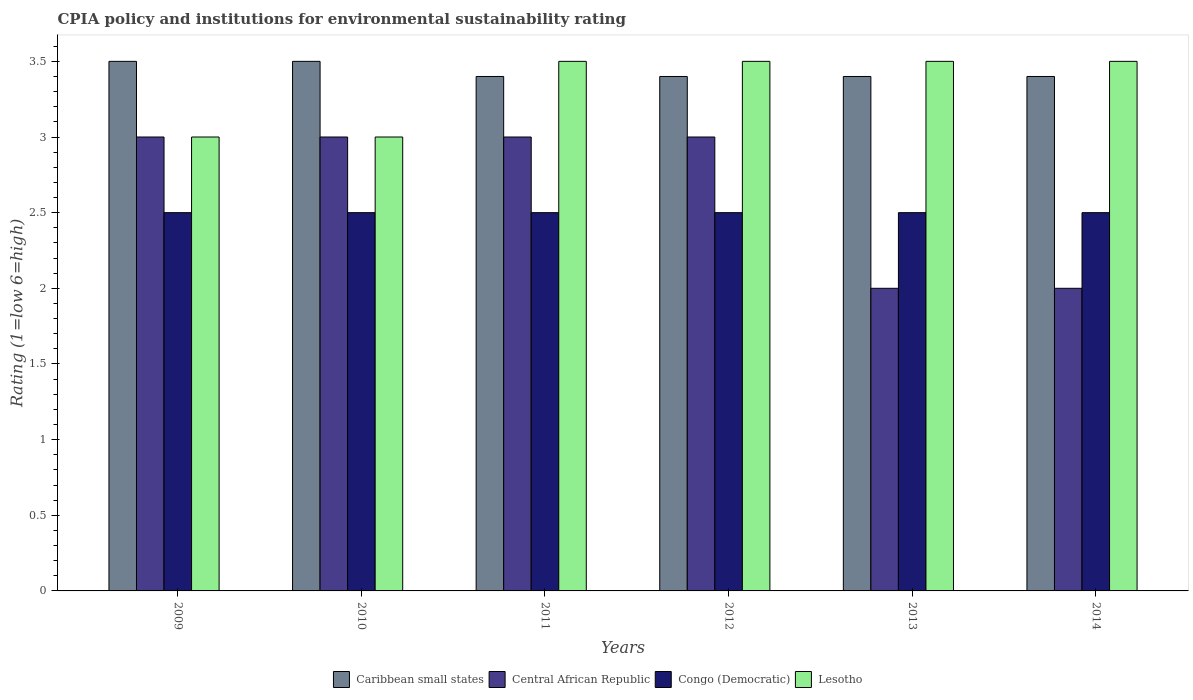How many groups of bars are there?
Your answer should be very brief. 6. Are the number of bars per tick equal to the number of legend labels?
Make the answer very short. Yes. Are the number of bars on each tick of the X-axis equal?
Your answer should be very brief. Yes. How many bars are there on the 3rd tick from the left?
Ensure brevity in your answer.  4. What is the label of the 4th group of bars from the left?
Your answer should be very brief. 2012. What is the CPIA rating in Congo (Democratic) in 2009?
Keep it short and to the point. 2.5. Across all years, what is the maximum CPIA rating in Lesotho?
Provide a short and direct response. 3.5. Across all years, what is the minimum CPIA rating in Congo (Democratic)?
Offer a very short reply. 2.5. In which year was the CPIA rating in Caribbean small states minimum?
Ensure brevity in your answer.  2011. What is the average CPIA rating in Central African Republic per year?
Your answer should be very brief. 2.67. In the year 2011, what is the difference between the CPIA rating in Lesotho and CPIA rating in Caribbean small states?
Your answer should be compact. 0.1. What is the difference between the highest and the second highest CPIA rating in Central African Republic?
Offer a terse response. 0. What is the difference between the highest and the lowest CPIA rating in Central African Republic?
Offer a terse response. 1. In how many years, is the CPIA rating in Congo (Democratic) greater than the average CPIA rating in Congo (Democratic) taken over all years?
Ensure brevity in your answer.  0. Is the sum of the CPIA rating in Lesotho in 2011 and 2012 greater than the maximum CPIA rating in Central African Republic across all years?
Make the answer very short. Yes. Is it the case that in every year, the sum of the CPIA rating in Central African Republic and CPIA rating in Lesotho is greater than the sum of CPIA rating in Caribbean small states and CPIA rating in Congo (Democratic)?
Make the answer very short. No. What does the 1st bar from the left in 2014 represents?
Provide a short and direct response. Caribbean small states. What does the 4th bar from the right in 2013 represents?
Ensure brevity in your answer.  Caribbean small states. How many bars are there?
Your answer should be compact. 24. Are the values on the major ticks of Y-axis written in scientific E-notation?
Make the answer very short. No. Does the graph contain any zero values?
Offer a terse response. No. Where does the legend appear in the graph?
Provide a short and direct response. Bottom center. How many legend labels are there?
Make the answer very short. 4. How are the legend labels stacked?
Your answer should be very brief. Horizontal. What is the title of the graph?
Ensure brevity in your answer.  CPIA policy and institutions for environmental sustainability rating. Does "Bahamas" appear as one of the legend labels in the graph?
Your answer should be compact. No. What is the label or title of the X-axis?
Provide a short and direct response. Years. What is the Rating (1=low 6=high) in Congo (Democratic) in 2009?
Your answer should be compact. 2.5. What is the Rating (1=low 6=high) in Congo (Democratic) in 2010?
Offer a very short reply. 2.5. What is the Rating (1=low 6=high) in Caribbean small states in 2011?
Provide a short and direct response. 3.4. What is the Rating (1=low 6=high) of Central African Republic in 2011?
Ensure brevity in your answer.  3. What is the Rating (1=low 6=high) of Lesotho in 2012?
Keep it short and to the point. 3.5. What is the Rating (1=low 6=high) in Caribbean small states in 2013?
Give a very brief answer. 3.4. What is the Rating (1=low 6=high) in Central African Republic in 2013?
Offer a very short reply. 2. What is the Rating (1=low 6=high) of Caribbean small states in 2014?
Provide a short and direct response. 3.4. What is the Rating (1=low 6=high) in Lesotho in 2014?
Your answer should be compact. 3.5. Across all years, what is the maximum Rating (1=low 6=high) of Caribbean small states?
Provide a short and direct response. 3.5. Across all years, what is the maximum Rating (1=low 6=high) in Central African Republic?
Make the answer very short. 3. Across all years, what is the minimum Rating (1=low 6=high) of Congo (Democratic)?
Offer a terse response. 2.5. What is the total Rating (1=low 6=high) in Caribbean small states in the graph?
Give a very brief answer. 20.6. What is the total Rating (1=low 6=high) of Congo (Democratic) in the graph?
Provide a succinct answer. 15. What is the difference between the Rating (1=low 6=high) of Central African Republic in 2009 and that in 2010?
Offer a very short reply. 0. What is the difference between the Rating (1=low 6=high) of Caribbean small states in 2009 and that in 2011?
Your answer should be compact. 0.1. What is the difference between the Rating (1=low 6=high) of Lesotho in 2009 and that in 2011?
Your answer should be compact. -0.5. What is the difference between the Rating (1=low 6=high) of Central African Republic in 2009 and that in 2012?
Ensure brevity in your answer.  0. What is the difference between the Rating (1=low 6=high) in Congo (Democratic) in 2009 and that in 2012?
Your answer should be very brief. 0. What is the difference between the Rating (1=low 6=high) in Lesotho in 2009 and that in 2012?
Offer a very short reply. -0.5. What is the difference between the Rating (1=low 6=high) of Lesotho in 2009 and that in 2013?
Ensure brevity in your answer.  -0.5. What is the difference between the Rating (1=low 6=high) in Caribbean small states in 2009 and that in 2014?
Offer a very short reply. 0.1. What is the difference between the Rating (1=low 6=high) of Congo (Democratic) in 2009 and that in 2014?
Provide a succinct answer. 0. What is the difference between the Rating (1=low 6=high) in Lesotho in 2009 and that in 2014?
Your answer should be very brief. -0.5. What is the difference between the Rating (1=low 6=high) in Caribbean small states in 2010 and that in 2011?
Give a very brief answer. 0.1. What is the difference between the Rating (1=low 6=high) of Central African Republic in 2010 and that in 2011?
Your response must be concise. 0. What is the difference between the Rating (1=low 6=high) in Caribbean small states in 2010 and that in 2012?
Keep it short and to the point. 0.1. What is the difference between the Rating (1=low 6=high) of Central African Republic in 2010 and that in 2012?
Your answer should be compact. 0. What is the difference between the Rating (1=low 6=high) in Caribbean small states in 2010 and that in 2013?
Keep it short and to the point. 0.1. What is the difference between the Rating (1=low 6=high) in Central African Republic in 2010 and that in 2013?
Your answer should be very brief. 1. What is the difference between the Rating (1=low 6=high) in Lesotho in 2010 and that in 2013?
Offer a terse response. -0.5. What is the difference between the Rating (1=low 6=high) in Central African Republic in 2010 and that in 2014?
Offer a very short reply. 1. What is the difference between the Rating (1=low 6=high) of Central African Republic in 2011 and that in 2012?
Your answer should be compact. 0. What is the difference between the Rating (1=low 6=high) in Lesotho in 2011 and that in 2012?
Provide a succinct answer. 0. What is the difference between the Rating (1=low 6=high) in Caribbean small states in 2011 and that in 2013?
Your response must be concise. 0. What is the difference between the Rating (1=low 6=high) in Central African Republic in 2011 and that in 2013?
Offer a very short reply. 1. What is the difference between the Rating (1=low 6=high) of Caribbean small states in 2012 and that in 2013?
Offer a very short reply. 0. What is the difference between the Rating (1=low 6=high) of Central African Republic in 2012 and that in 2013?
Your response must be concise. 1. What is the difference between the Rating (1=low 6=high) of Congo (Democratic) in 2012 and that in 2013?
Your response must be concise. 0. What is the difference between the Rating (1=low 6=high) in Lesotho in 2012 and that in 2013?
Ensure brevity in your answer.  0. What is the difference between the Rating (1=low 6=high) of Central African Republic in 2012 and that in 2014?
Offer a terse response. 1. What is the difference between the Rating (1=low 6=high) in Congo (Democratic) in 2012 and that in 2014?
Make the answer very short. 0. What is the difference between the Rating (1=low 6=high) of Lesotho in 2012 and that in 2014?
Provide a short and direct response. 0. What is the difference between the Rating (1=low 6=high) of Congo (Democratic) in 2013 and that in 2014?
Your answer should be compact. 0. What is the difference between the Rating (1=low 6=high) in Caribbean small states in 2009 and the Rating (1=low 6=high) in Central African Republic in 2010?
Offer a terse response. 0.5. What is the difference between the Rating (1=low 6=high) of Central African Republic in 2009 and the Rating (1=low 6=high) of Congo (Democratic) in 2010?
Your answer should be very brief. 0.5. What is the difference between the Rating (1=low 6=high) in Congo (Democratic) in 2009 and the Rating (1=low 6=high) in Lesotho in 2010?
Give a very brief answer. -0.5. What is the difference between the Rating (1=low 6=high) of Caribbean small states in 2009 and the Rating (1=low 6=high) of Lesotho in 2011?
Your answer should be compact. 0. What is the difference between the Rating (1=low 6=high) in Central African Republic in 2009 and the Rating (1=low 6=high) in Lesotho in 2011?
Make the answer very short. -0.5. What is the difference between the Rating (1=low 6=high) of Caribbean small states in 2009 and the Rating (1=low 6=high) of Congo (Democratic) in 2012?
Make the answer very short. 1. What is the difference between the Rating (1=low 6=high) of Central African Republic in 2009 and the Rating (1=low 6=high) of Lesotho in 2012?
Keep it short and to the point. -0.5. What is the difference between the Rating (1=low 6=high) of Congo (Democratic) in 2009 and the Rating (1=low 6=high) of Lesotho in 2012?
Ensure brevity in your answer.  -1. What is the difference between the Rating (1=low 6=high) in Caribbean small states in 2009 and the Rating (1=low 6=high) in Central African Republic in 2013?
Give a very brief answer. 1.5. What is the difference between the Rating (1=low 6=high) in Caribbean small states in 2009 and the Rating (1=low 6=high) in Lesotho in 2013?
Ensure brevity in your answer.  0. What is the difference between the Rating (1=low 6=high) of Caribbean small states in 2009 and the Rating (1=low 6=high) of Central African Republic in 2014?
Offer a very short reply. 1.5. What is the difference between the Rating (1=low 6=high) of Central African Republic in 2009 and the Rating (1=low 6=high) of Congo (Democratic) in 2014?
Ensure brevity in your answer.  0.5. What is the difference between the Rating (1=low 6=high) of Central African Republic in 2009 and the Rating (1=low 6=high) of Lesotho in 2014?
Give a very brief answer. -0.5. What is the difference between the Rating (1=low 6=high) of Congo (Democratic) in 2009 and the Rating (1=low 6=high) of Lesotho in 2014?
Offer a terse response. -1. What is the difference between the Rating (1=low 6=high) in Congo (Democratic) in 2010 and the Rating (1=low 6=high) in Lesotho in 2011?
Your response must be concise. -1. What is the difference between the Rating (1=low 6=high) of Caribbean small states in 2010 and the Rating (1=low 6=high) of Central African Republic in 2012?
Your answer should be very brief. 0.5. What is the difference between the Rating (1=low 6=high) of Caribbean small states in 2010 and the Rating (1=low 6=high) of Congo (Democratic) in 2012?
Offer a very short reply. 1. What is the difference between the Rating (1=low 6=high) of Caribbean small states in 2010 and the Rating (1=low 6=high) of Lesotho in 2012?
Ensure brevity in your answer.  0. What is the difference between the Rating (1=low 6=high) in Caribbean small states in 2010 and the Rating (1=low 6=high) in Central African Republic in 2013?
Provide a succinct answer. 1.5. What is the difference between the Rating (1=low 6=high) in Caribbean small states in 2010 and the Rating (1=low 6=high) in Lesotho in 2013?
Your answer should be compact. 0. What is the difference between the Rating (1=low 6=high) of Central African Republic in 2010 and the Rating (1=low 6=high) of Lesotho in 2013?
Ensure brevity in your answer.  -0.5. What is the difference between the Rating (1=low 6=high) of Congo (Democratic) in 2010 and the Rating (1=low 6=high) of Lesotho in 2013?
Provide a short and direct response. -1. What is the difference between the Rating (1=low 6=high) in Caribbean small states in 2010 and the Rating (1=low 6=high) in Central African Republic in 2014?
Provide a short and direct response. 1.5. What is the difference between the Rating (1=low 6=high) in Caribbean small states in 2010 and the Rating (1=low 6=high) in Lesotho in 2014?
Provide a succinct answer. 0. What is the difference between the Rating (1=low 6=high) in Central African Republic in 2010 and the Rating (1=low 6=high) in Lesotho in 2014?
Give a very brief answer. -0.5. What is the difference between the Rating (1=low 6=high) of Caribbean small states in 2011 and the Rating (1=low 6=high) of Central African Republic in 2012?
Ensure brevity in your answer.  0.4. What is the difference between the Rating (1=low 6=high) of Caribbean small states in 2011 and the Rating (1=low 6=high) of Congo (Democratic) in 2012?
Your answer should be compact. 0.9. What is the difference between the Rating (1=low 6=high) in Central African Republic in 2011 and the Rating (1=low 6=high) in Congo (Democratic) in 2012?
Your response must be concise. 0.5. What is the difference between the Rating (1=low 6=high) in Caribbean small states in 2011 and the Rating (1=low 6=high) in Central African Republic in 2013?
Keep it short and to the point. 1.4. What is the difference between the Rating (1=low 6=high) of Central African Republic in 2011 and the Rating (1=low 6=high) of Lesotho in 2013?
Keep it short and to the point. -0.5. What is the difference between the Rating (1=low 6=high) of Congo (Democratic) in 2011 and the Rating (1=low 6=high) of Lesotho in 2013?
Provide a short and direct response. -1. What is the difference between the Rating (1=low 6=high) in Caribbean small states in 2011 and the Rating (1=low 6=high) in Congo (Democratic) in 2014?
Your answer should be compact. 0.9. What is the difference between the Rating (1=low 6=high) of Central African Republic in 2011 and the Rating (1=low 6=high) of Congo (Democratic) in 2014?
Offer a terse response. 0.5. What is the difference between the Rating (1=low 6=high) in Caribbean small states in 2012 and the Rating (1=low 6=high) in Central African Republic in 2013?
Offer a very short reply. 1.4. What is the difference between the Rating (1=low 6=high) of Central African Republic in 2012 and the Rating (1=low 6=high) of Congo (Democratic) in 2013?
Your answer should be compact. 0.5. What is the difference between the Rating (1=low 6=high) of Congo (Democratic) in 2012 and the Rating (1=low 6=high) of Lesotho in 2013?
Your answer should be very brief. -1. What is the difference between the Rating (1=low 6=high) of Caribbean small states in 2012 and the Rating (1=low 6=high) of Central African Republic in 2014?
Your response must be concise. 1.4. What is the difference between the Rating (1=low 6=high) of Caribbean small states in 2012 and the Rating (1=low 6=high) of Congo (Democratic) in 2014?
Your answer should be compact. 0.9. What is the difference between the Rating (1=low 6=high) of Caribbean small states in 2012 and the Rating (1=low 6=high) of Lesotho in 2014?
Provide a short and direct response. -0.1. What is the difference between the Rating (1=low 6=high) in Central African Republic in 2012 and the Rating (1=low 6=high) in Congo (Democratic) in 2014?
Offer a terse response. 0.5. What is the difference between the Rating (1=low 6=high) of Congo (Democratic) in 2012 and the Rating (1=low 6=high) of Lesotho in 2014?
Provide a short and direct response. -1. What is the difference between the Rating (1=low 6=high) of Caribbean small states in 2013 and the Rating (1=low 6=high) of Central African Republic in 2014?
Provide a succinct answer. 1.4. What is the difference between the Rating (1=low 6=high) in Caribbean small states in 2013 and the Rating (1=low 6=high) in Congo (Democratic) in 2014?
Offer a very short reply. 0.9. What is the difference between the Rating (1=low 6=high) in Caribbean small states in 2013 and the Rating (1=low 6=high) in Lesotho in 2014?
Provide a short and direct response. -0.1. What is the difference between the Rating (1=low 6=high) in Central African Republic in 2013 and the Rating (1=low 6=high) in Congo (Democratic) in 2014?
Make the answer very short. -0.5. What is the difference between the Rating (1=low 6=high) in Central African Republic in 2013 and the Rating (1=low 6=high) in Lesotho in 2014?
Keep it short and to the point. -1.5. What is the average Rating (1=low 6=high) in Caribbean small states per year?
Offer a very short reply. 3.43. What is the average Rating (1=low 6=high) in Central African Republic per year?
Your answer should be very brief. 2.67. In the year 2009, what is the difference between the Rating (1=low 6=high) of Congo (Democratic) and Rating (1=low 6=high) of Lesotho?
Offer a terse response. -0.5. In the year 2010, what is the difference between the Rating (1=low 6=high) in Caribbean small states and Rating (1=low 6=high) in Congo (Democratic)?
Your answer should be compact. 1. In the year 2010, what is the difference between the Rating (1=low 6=high) of Caribbean small states and Rating (1=low 6=high) of Lesotho?
Offer a very short reply. 0.5. In the year 2010, what is the difference between the Rating (1=low 6=high) of Central African Republic and Rating (1=low 6=high) of Congo (Democratic)?
Keep it short and to the point. 0.5. In the year 2010, what is the difference between the Rating (1=low 6=high) in Congo (Democratic) and Rating (1=low 6=high) in Lesotho?
Ensure brevity in your answer.  -0.5. In the year 2011, what is the difference between the Rating (1=low 6=high) of Caribbean small states and Rating (1=low 6=high) of Lesotho?
Your response must be concise. -0.1. In the year 2011, what is the difference between the Rating (1=low 6=high) of Central African Republic and Rating (1=low 6=high) of Lesotho?
Provide a short and direct response. -0.5. In the year 2011, what is the difference between the Rating (1=low 6=high) of Congo (Democratic) and Rating (1=low 6=high) of Lesotho?
Provide a short and direct response. -1. In the year 2012, what is the difference between the Rating (1=low 6=high) of Caribbean small states and Rating (1=low 6=high) of Central African Republic?
Your answer should be very brief. 0.4. In the year 2012, what is the difference between the Rating (1=low 6=high) of Caribbean small states and Rating (1=low 6=high) of Congo (Democratic)?
Give a very brief answer. 0.9. In the year 2012, what is the difference between the Rating (1=low 6=high) in Caribbean small states and Rating (1=low 6=high) in Lesotho?
Provide a succinct answer. -0.1. In the year 2012, what is the difference between the Rating (1=low 6=high) of Central African Republic and Rating (1=low 6=high) of Congo (Democratic)?
Provide a succinct answer. 0.5. In the year 2012, what is the difference between the Rating (1=low 6=high) in Central African Republic and Rating (1=low 6=high) in Lesotho?
Give a very brief answer. -0.5. In the year 2012, what is the difference between the Rating (1=low 6=high) in Congo (Democratic) and Rating (1=low 6=high) in Lesotho?
Your response must be concise. -1. In the year 2013, what is the difference between the Rating (1=low 6=high) of Caribbean small states and Rating (1=low 6=high) of Central African Republic?
Offer a very short reply. 1.4. In the year 2013, what is the difference between the Rating (1=low 6=high) of Central African Republic and Rating (1=low 6=high) of Congo (Democratic)?
Provide a short and direct response. -0.5. In the year 2013, what is the difference between the Rating (1=low 6=high) in Central African Republic and Rating (1=low 6=high) in Lesotho?
Offer a very short reply. -1.5. In the year 2013, what is the difference between the Rating (1=low 6=high) in Congo (Democratic) and Rating (1=low 6=high) in Lesotho?
Your answer should be compact. -1. In the year 2014, what is the difference between the Rating (1=low 6=high) in Central African Republic and Rating (1=low 6=high) in Lesotho?
Your response must be concise. -1.5. In the year 2014, what is the difference between the Rating (1=low 6=high) of Congo (Democratic) and Rating (1=low 6=high) of Lesotho?
Provide a succinct answer. -1. What is the ratio of the Rating (1=low 6=high) in Caribbean small states in 2009 to that in 2010?
Offer a terse response. 1. What is the ratio of the Rating (1=low 6=high) of Congo (Democratic) in 2009 to that in 2010?
Give a very brief answer. 1. What is the ratio of the Rating (1=low 6=high) in Caribbean small states in 2009 to that in 2011?
Ensure brevity in your answer.  1.03. What is the ratio of the Rating (1=low 6=high) in Lesotho in 2009 to that in 2011?
Your answer should be compact. 0.86. What is the ratio of the Rating (1=low 6=high) in Caribbean small states in 2009 to that in 2012?
Your answer should be compact. 1.03. What is the ratio of the Rating (1=low 6=high) of Caribbean small states in 2009 to that in 2013?
Your response must be concise. 1.03. What is the ratio of the Rating (1=low 6=high) of Caribbean small states in 2009 to that in 2014?
Your response must be concise. 1.03. What is the ratio of the Rating (1=low 6=high) of Caribbean small states in 2010 to that in 2011?
Provide a short and direct response. 1.03. What is the ratio of the Rating (1=low 6=high) in Central African Republic in 2010 to that in 2011?
Give a very brief answer. 1. What is the ratio of the Rating (1=low 6=high) of Lesotho in 2010 to that in 2011?
Ensure brevity in your answer.  0.86. What is the ratio of the Rating (1=low 6=high) of Caribbean small states in 2010 to that in 2012?
Your answer should be very brief. 1.03. What is the ratio of the Rating (1=low 6=high) in Central African Republic in 2010 to that in 2012?
Your answer should be very brief. 1. What is the ratio of the Rating (1=low 6=high) in Lesotho in 2010 to that in 2012?
Give a very brief answer. 0.86. What is the ratio of the Rating (1=low 6=high) in Caribbean small states in 2010 to that in 2013?
Your answer should be compact. 1.03. What is the ratio of the Rating (1=low 6=high) in Lesotho in 2010 to that in 2013?
Offer a terse response. 0.86. What is the ratio of the Rating (1=low 6=high) in Caribbean small states in 2010 to that in 2014?
Give a very brief answer. 1.03. What is the ratio of the Rating (1=low 6=high) of Congo (Democratic) in 2010 to that in 2014?
Offer a terse response. 1. What is the ratio of the Rating (1=low 6=high) of Caribbean small states in 2011 to that in 2012?
Offer a terse response. 1. What is the ratio of the Rating (1=low 6=high) of Central African Republic in 2011 to that in 2012?
Your answer should be compact. 1. What is the ratio of the Rating (1=low 6=high) in Congo (Democratic) in 2011 to that in 2013?
Give a very brief answer. 1. What is the ratio of the Rating (1=low 6=high) of Lesotho in 2011 to that in 2014?
Offer a very short reply. 1. What is the ratio of the Rating (1=low 6=high) of Caribbean small states in 2012 to that in 2013?
Provide a succinct answer. 1. What is the ratio of the Rating (1=low 6=high) in Lesotho in 2012 to that in 2013?
Your answer should be very brief. 1. What is the ratio of the Rating (1=low 6=high) in Central African Republic in 2012 to that in 2014?
Provide a short and direct response. 1.5. What is the ratio of the Rating (1=low 6=high) in Congo (Democratic) in 2012 to that in 2014?
Your answer should be very brief. 1. What is the ratio of the Rating (1=low 6=high) in Lesotho in 2013 to that in 2014?
Give a very brief answer. 1. What is the difference between the highest and the second highest Rating (1=low 6=high) of Lesotho?
Provide a succinct answer. 0. What is the difference between the highest and the lowest Rating (1=low 6=high) of Caribbean small states?
Keep it short and to the point. 0.1. What is the difference between the highest and the lowest Rating (1=low 6=high) in Central African Republic?
Provide a succinct answer. 1. 